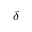<formula> <loc_0><loc_0><loc_500><loc_500>\delta</formula> 